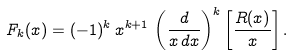<formula> <loc_0><loc_0><loc_500><loc_500>F _ { k } ( x ) = ( - 1 ) ^ { k } \, x ^ { k + 1 } \, \left ( \frac { d } { x \, d x } \right ) ^ { k } \left [ \frac { R ( x ) } { x } \right ] .</formula> 